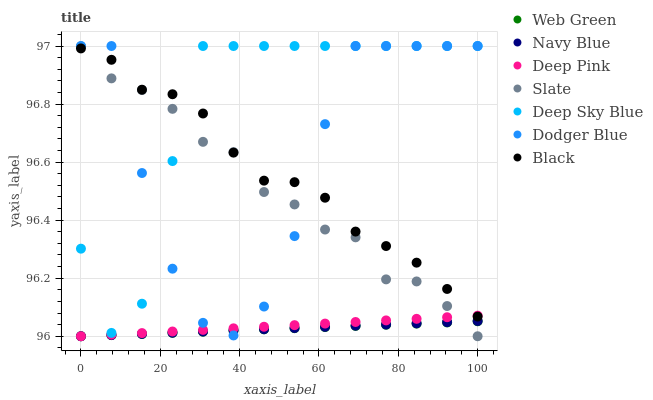Does Web Green have the minimum area under the curve?
Answer yes or no. Yes. Does Deep Sky Blue have the maximum area under the curve?
Answer yes or no. Yes. Does Navy Blue have the minimum area under the curve?
Answer yes or no. No. Does Navy Blue have the maximum area under the curve?
Answer yes or no. No. Is Navy Blue the smoothest?
Answer yes or no. Yes. Is Dodger Blue the roughest?
Answer yes or no. Yes. Is Slate the smoothest?
Answer yes or no. No. Is Slate the roughest?
Answer yes or no. No. Does Deep Pink have the lowest value?
Answer yes or no. Yes. Does Dodger Blue have the lowest value?
Answer yes or no. No. Does Deep Sky Blue have the highest value?
Answer yes or no. Yes. Does Navy Blue have the highest value?
Answer yes or no. No. Is Web Green less than Deep Sky Blue?
Answer yes or no. Yes. Is Deep Sky Blue greater than Deep Pink?
Answer yes or no. Yes. Does Deep Pink intersect Dodger Blue?
Answer yes or no. Yes. Is Deep Pink less than Dodger Blue?
Answer yes or no. No. Is Deep Pink greater than Dodger Blue?
Answer yes or no. No. Does Web Green intersect Deep Sky Blue?
Answer yes or no. No. 